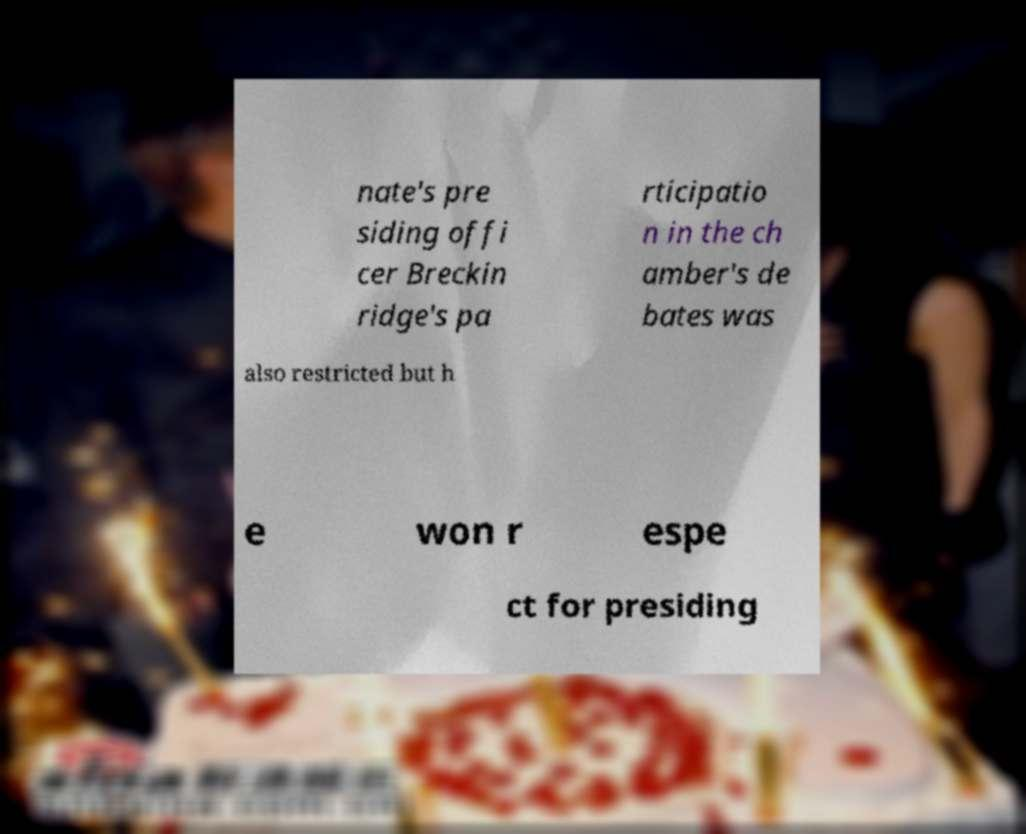Please identify and transcribe the text found in this image. nate's pre siding offi cer Breckin ridge's pa rticipatio n in the ch amber's de bates was also restricted but h e won r espe ct for presiding 